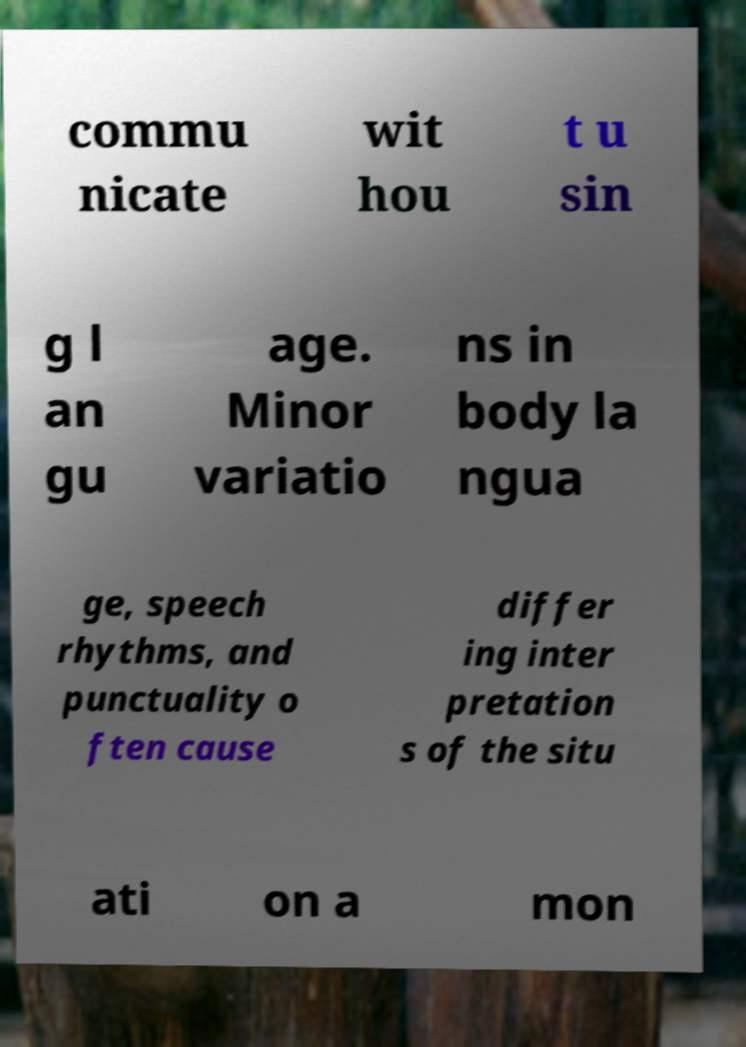I need the written content from this picture converted into text. Can you do that? commu nicate wit hou t u sin g l an gu age. Minor variatio ns in body la ngua ge, speech rhythms, and punctuality o ften cause differ ing inter pretation s of the situ ati on a mon 